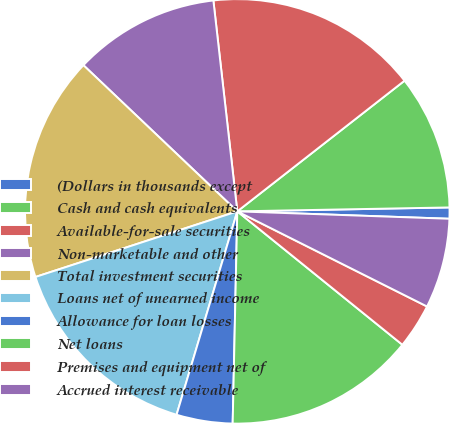Convert chart. <chart><loc_0><loc_0><loc_500><loc_500><pie_chart><fcel>(Dollars in thousands except<fcel>Cash and cash equivalents<fcel>Available-for-sale securities<fcel>Non-marketable and other<fcel>Total investment securities<fcel>Loans net of unearned income<fcel>Allowance for loan losses<fcel>Net loans<fcel>Premises and equipment net of<fcel>Accrued interest receivable<nl><fcel>0.85%<fcel>10.26%<fcel>16.24%<fcel>11.11%<fcel>17.09%<fcel>15.38%<fcel>4.27%<fcel>14.53%<fcel>3.42%<fcel>6.84%<nl></chart> 